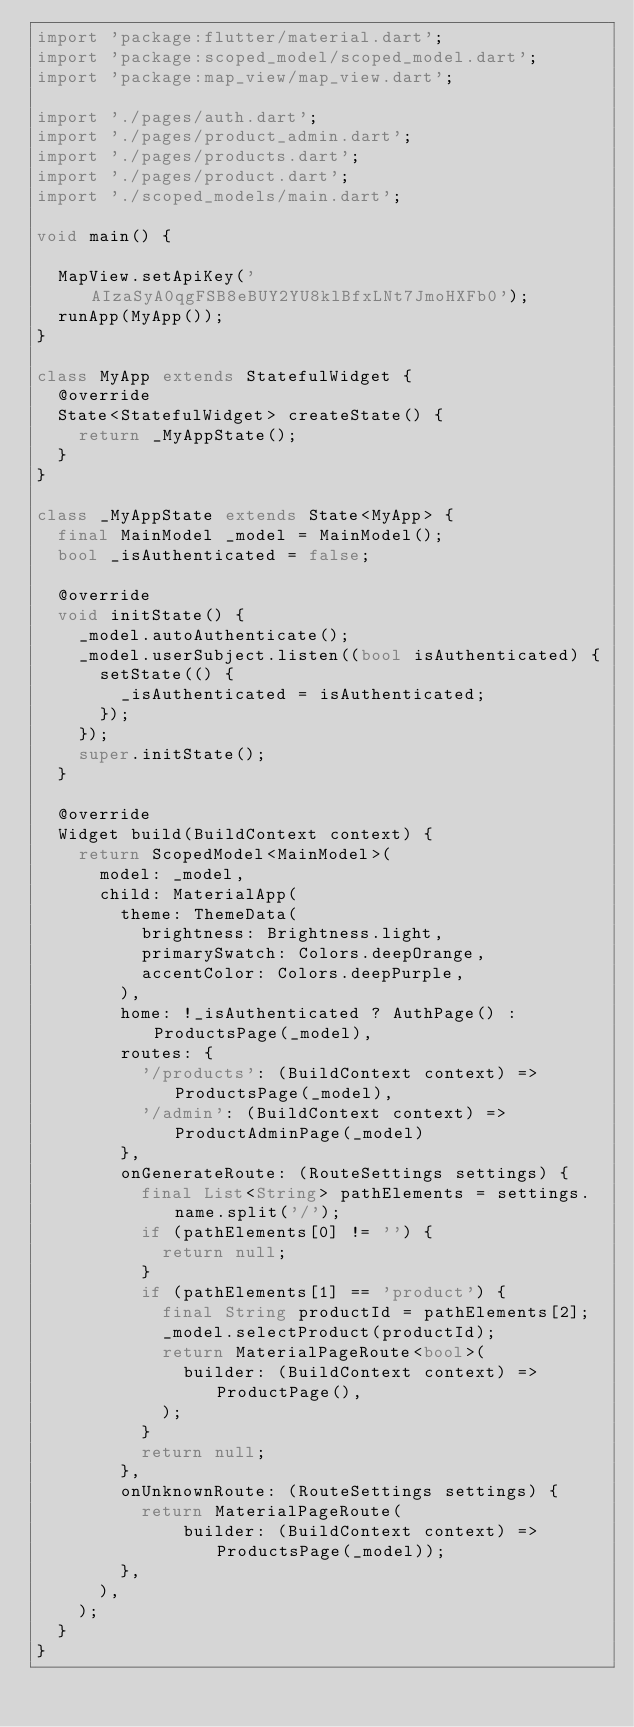Convert code to text. <code><loc_0><loc_0><loc_500><loc_500><_Dart_>import 'package:flutter/material.dart';
import 'package:scoped_model/scoped_model.dart';
import 'package:map_view/map_view.dart';

import './pages/auth.dart';
import './pages/product_admin.dart';
import './pages/products.dart';
import './pages/product.dart';
import './scoped_models/main.dart';

void main() {

  MapView.setApiKey('AIzaSyA0qgFSB8eBUY2YU8klBfxLNt7JmoHXFb0');
  runApp(MyApp());
}

class MyApp extends StatefulWidget {
  @override
  State<StatefulWidget> createState() {
    return _MyAppState();
  }
}

class _MyAppState extends State<MyApp> {
  final MainModel _model = MainModel();
  bool _isAuthenticated = false;

  @override
  void initState() {
    _model.autoAuthenticate();
    _model.userSubject.listen((bool isAuthenticated) {
      setState(() {
        _isAuthenticated = isAuthenticated;
      });
    });
    super.initState();
  }

  @override
  Widget build(BuildContext context) {
    return ScopedModel<MainModel>(
      model: _model,
      child: MaterialApp(
        theme: ThemeData(
          brightness: Brightness.light,
          primarySwatch: Colors.deepOrange,
          accentColor: Colors.deepPurple,
        ),
        home: !_isAuthenticated ? AuthPage() : ProductsPage(_model),
        routes: {
          '/products': (BuildContext context) => ProductsPage(_model),
          '/admin': (BuildContext context) => ProductAdminPage(_model)
        },
        onGenerateRoute: (RouteSettings settings) {
          final List<String> pathElements = settings.name.split('/');
          if (pathElements[0] != '') {
            return null;
          }
          if (pathElements[1] == 'product') {
            final String productId = pathElements[2];
            _model.selectProduct(productId);
            return MaterialPageRoute<bool>(
              builder: (BuildContext context) => ProductPage(),
            );
          }
          return null;
        },
        onUnknownRoute: (RouteSettings settings) {
          return MaterialPageRoute(
              builder: (BuildContext context) => ProductsPage(_model));
        },
      ),
    );
  }
}
</code> 